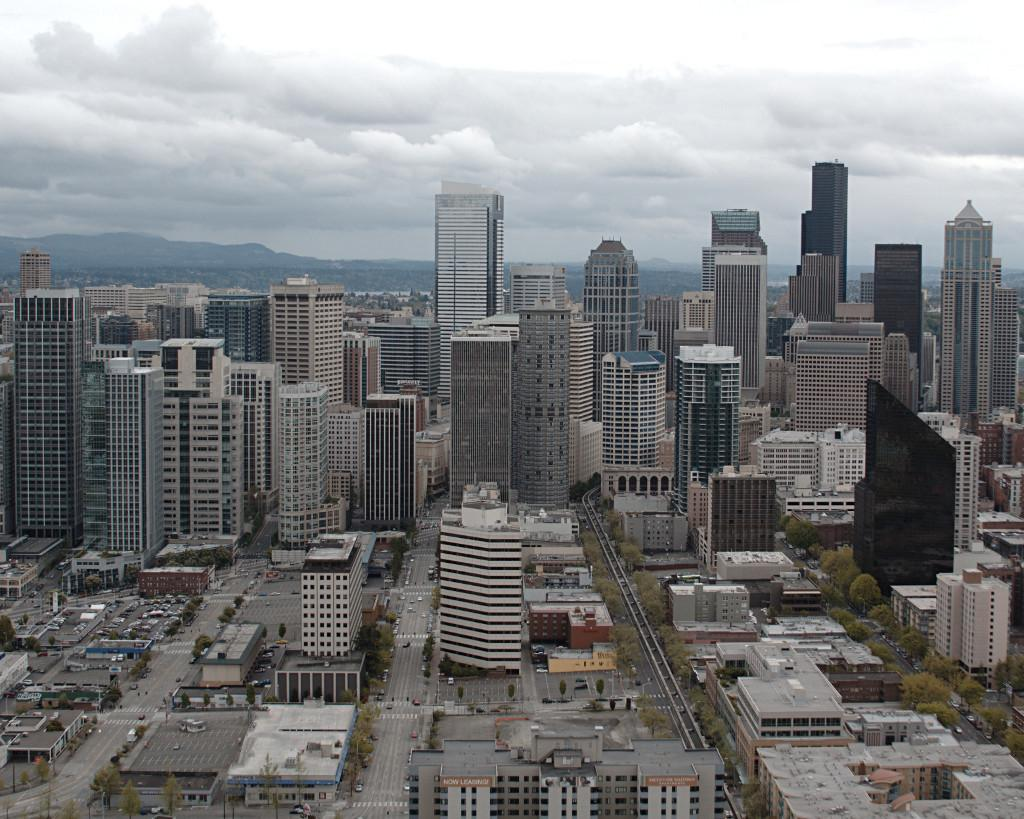What type of structures can be seen in the image? There are buildings in the image. What other natural elements are present in the image? There are trees in the image. Are there any man-made objects visible besides the buildings? Yes, there are vehicles in the image. What can be seen in the background of the image? The sky is visible in the background of the image, and there are clouds in the sky. What type of bushes can be seen in the image? There are no bushes present in the image. What scent is associated with the image? The image does not have a scent, as it is a visual representation. 